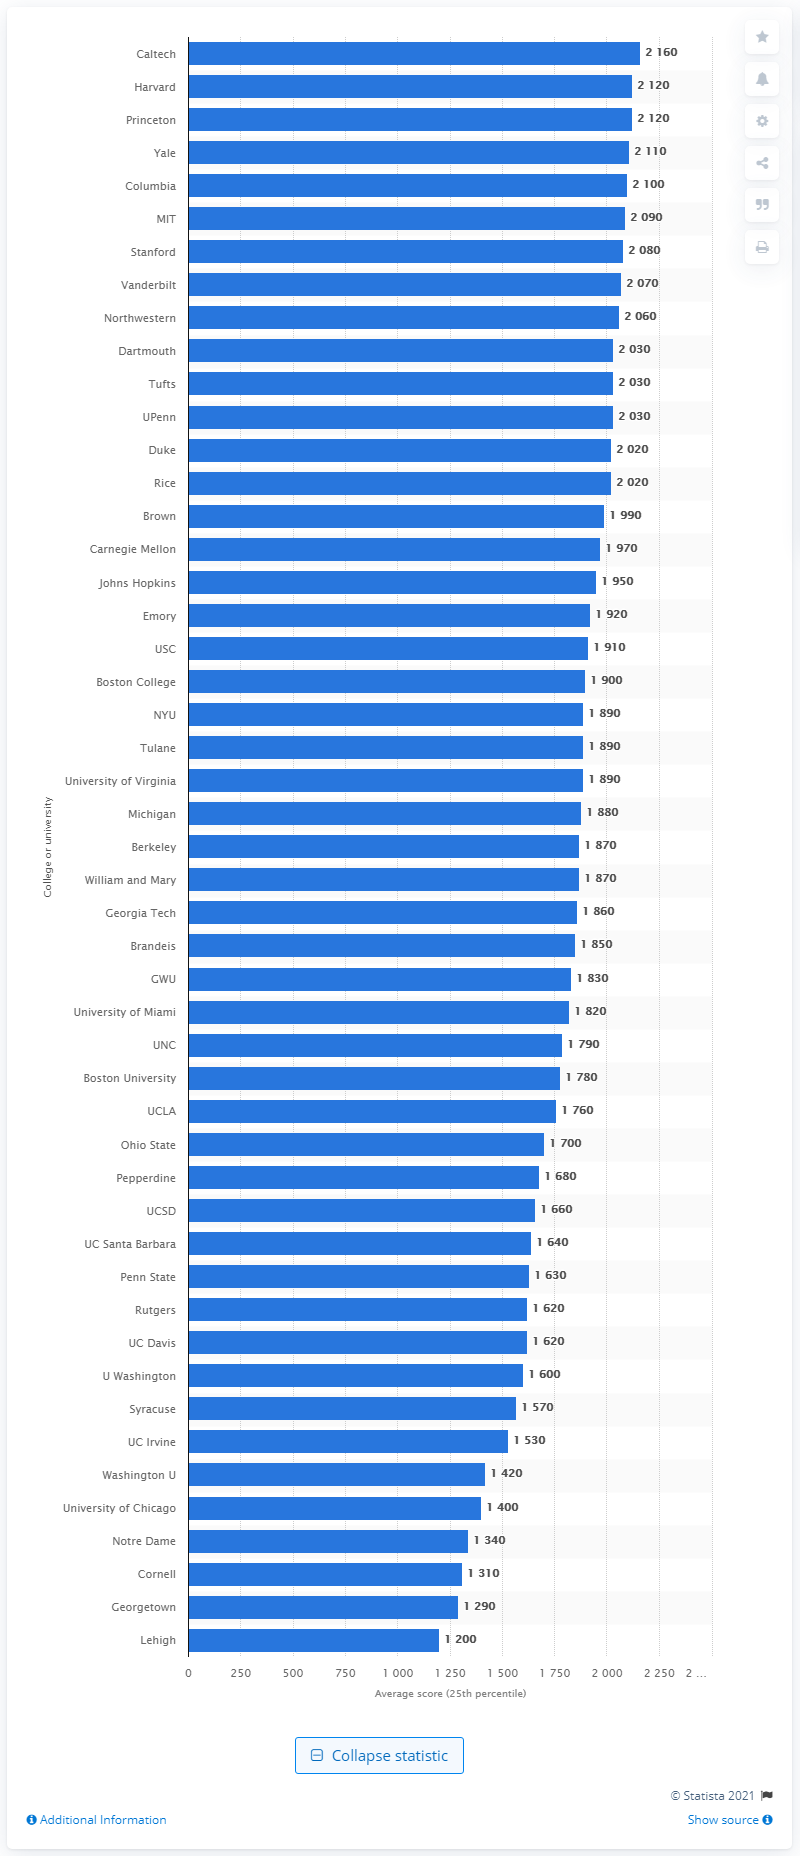Draw attention to some important aspects in this diagram. In 2012-2013, the minimum SAT score required for admission to Harvard was 2120. 